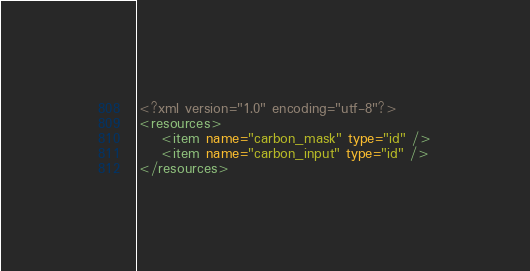Convert code to text. <code><loc_0><loc_0><loc_500><loc_500><_XML_><?xml version="1.0" encoding="utf-8"?>
<resources>
    <item name="carbon_mask" type="id" />
    <item name="carbon_input" type="id" />
</resources></code> 